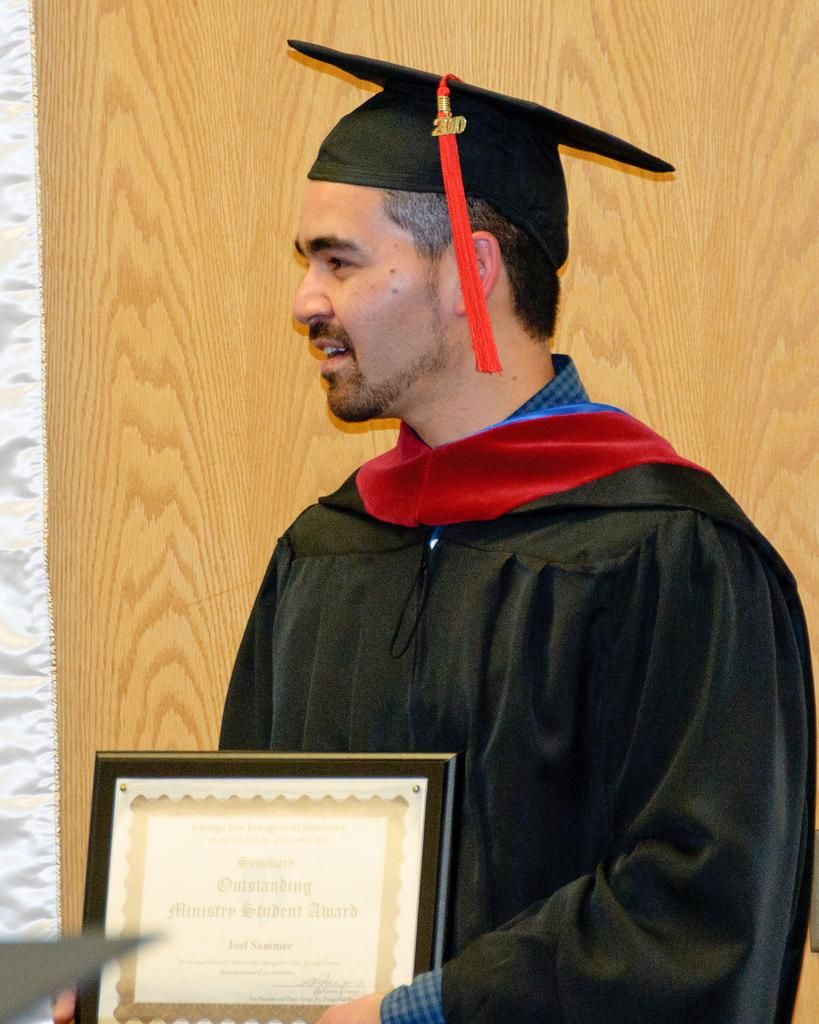Who is present in the image? There is a man in the picture. What is the man standing near? The man is standing near a wooden wall. What is the man holding in the image? The man is holding a certificate with a frame. What type of sleet can be seen falling near the seashore in the image? There is no seashore or sleet present in the image; it features a man standing near a wooden wall while holding a framed certificate. 